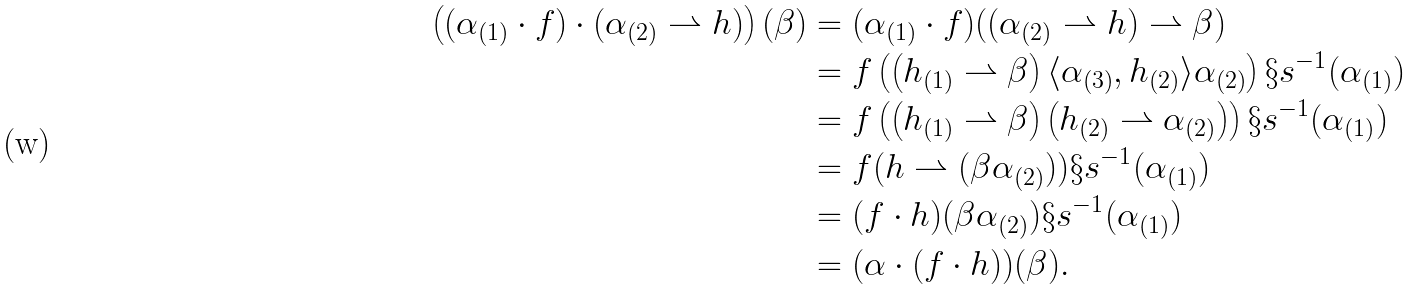<formula> <loc_0><loc_0><loc_500><loc_500>\left ( ( \alpha _ { ( 1 ) } \cdot f ) \cdot ( \alpha _ { ( 2 ) } \rightharpoonup h ) \right ) ( \beta ) & = ( \alpha _ { ( 1 ) } \cdot f ) ( ( \alpha _ { ( 2 ) } \rightharpoonup h ) \rightharpoonup \beta ) \\ & = f \left ( \left ( h _ { ( 1 ) } \rightharpoonup \beta \right ) \langle \alpha _ { ( 3 ) } , h _ { ( 2 ) } \rangle \alpha _ { ( 2 ) } \right ) \S s ^ { - 1 } ( \alpha _ { ( 1 ) } ) \\ & = f \left ( \left ( h _ { ( 1 ) } \rightharpoonup \beta \right ) \left ( h _ { ( 2 ) } \rightharpoonup \alpha _ { ( 2 ) } \right ) \right ) \S s ^ { - 1 } ( \alpha _ { ( 1 ) } ) \\ & = f ( h \rightharpoonup ( \beta \alpha _ { ( 2 ) } ) ) \S s ^ { - 1 } ( \alpha _ { ( 1 ) } ) \\ & = ( f \cdot h ) ( \beta \alpha _ { ( 2 ) } ) \S s ^ { - 1 } ( \alpha _ { ( 1 ) } ) \\ & = ( \alpha \cdot ( f \cdot h ) ) ( \beta ) .</formula> 